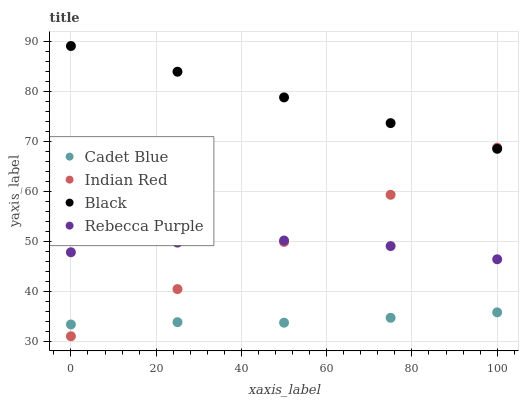Does Cadet Blue have the minimum area under the curve?
Answer yes or no. Yes. Does Black have the maximum area under the curve?
Answer yes or no. Yes. Does Rebecca Purple have the minimum area under the curve?
Answer yes or no. No. Does Rebecca Purple have the maximum area under the curve?
Answer yes or no. No. Is Black the smoothest?
Answer yes or no. Yes. Is Rebecca Purple the roughest?
Answer yes or no. Yes. Is Rebecca Purple the smoothest?
Answer yes or no. No. Is Black the roughest?
Answer yes or no. No. Does Indian Red have the lowest value?
Answer yes or no. Yes. Does Rebecca Purple have the lowest value?
Answer yes or no. No. Does Black have the highest value?
Answer yes or no. Yes. Does Rebecca Purple have the highest value?
Answer yes or no. No. Is Rebecca Purple less than Black?
Answer yes or no. Yes. Is Black greater than Rebecca Purple?
Answer yes or no. Yes. Does Indian Red intersect Rebecca Purple?
Answer yes or no. Yes. Is Indian Red less than Rebecca Purple?
Answer yes or no. No. Is Indian Red greater than Rebecca Purple?
Answer yes or no. No. Does Rebecca Purple intersect Black?
Answer yes or no. No. 